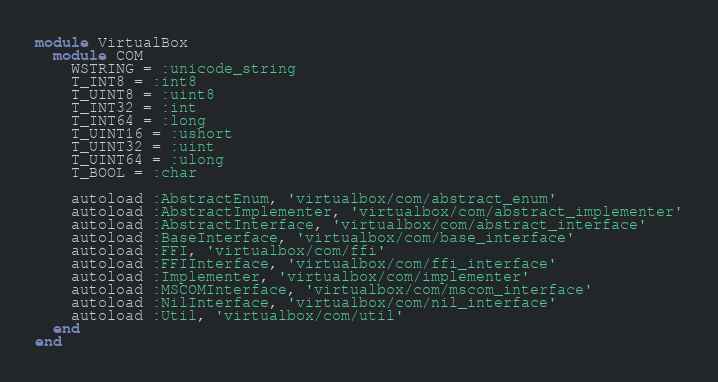<code> <loc_0><loc_0><loc_500><loc_500><_Ruby_>module VirtualBox
  module COM
    WSTRING = :unicode_string
    T_INT8 = :int8
    T_UINT8 = :uint8
    T_INT32 = :int
    T_INT64 = :long
    T_UINT16 = :ushort
    T_UINT32 = :uint
    T_UINT64 = :ulong
    T_BOOL = :char

    autoload :AbstractEnum, 'virtualbox/com/abstract_enum'
    autoload :AbstractImplementer, 'virtualbox/com/abstract_implementer'
    autoload :AbstractInterface, 'virtualbox/com/abstract_interface'
    autoload :BaseInterface, 'virtualbox/com/base_interface'
    autoload :FFI, 'virtualbox/com/ffi'
    autoload :FFIInterface, 'virtualbox/com/ffi_interface'
    autoload :Implementer, 'virtualbox/com/implementer'
    autoload :MSCOMInterface, 'virtualbox/com/mscom_interface'
    autoload :NilInterface, 'virtualbox/com/nil_interface'
    autoload :Util, 'virtualbox/com/util'
  end
end
</code> 